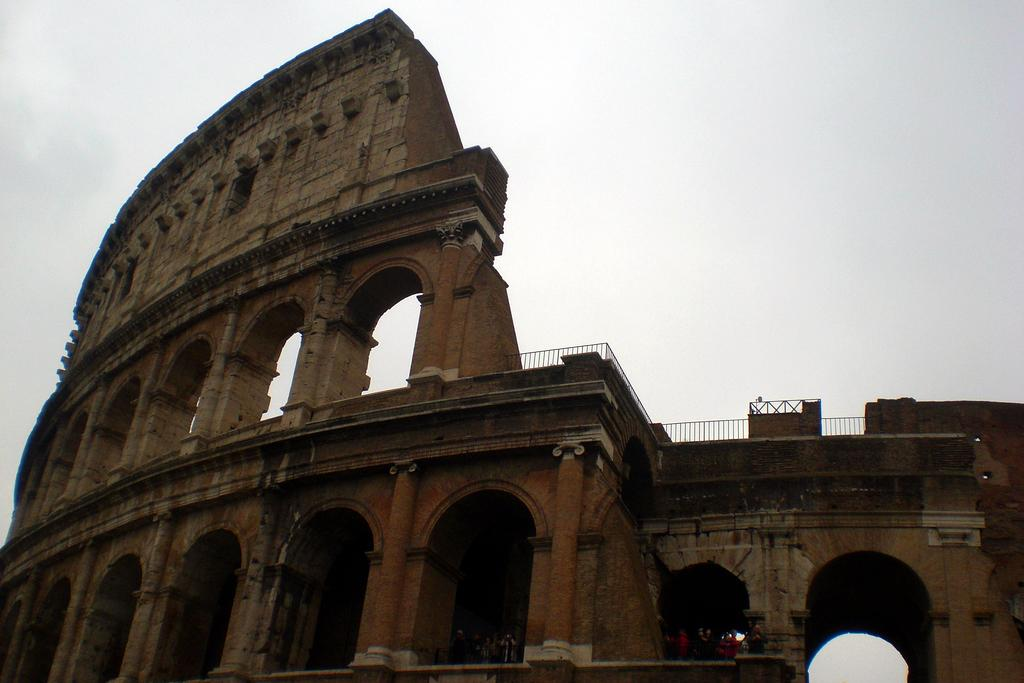What type of structure is present in the image? There is a building in the image. What is the color of the building? The building is brown in color. What feature can be seen near the building? There is railing in the image. What can be seen in the background of the image? The sky is visible in the background of the image. What type of wilderness can be seen surrounding the building in the image? There is no wilderness visible in the image; it features a building with a brown color and railing, with the sky visible in the background. 